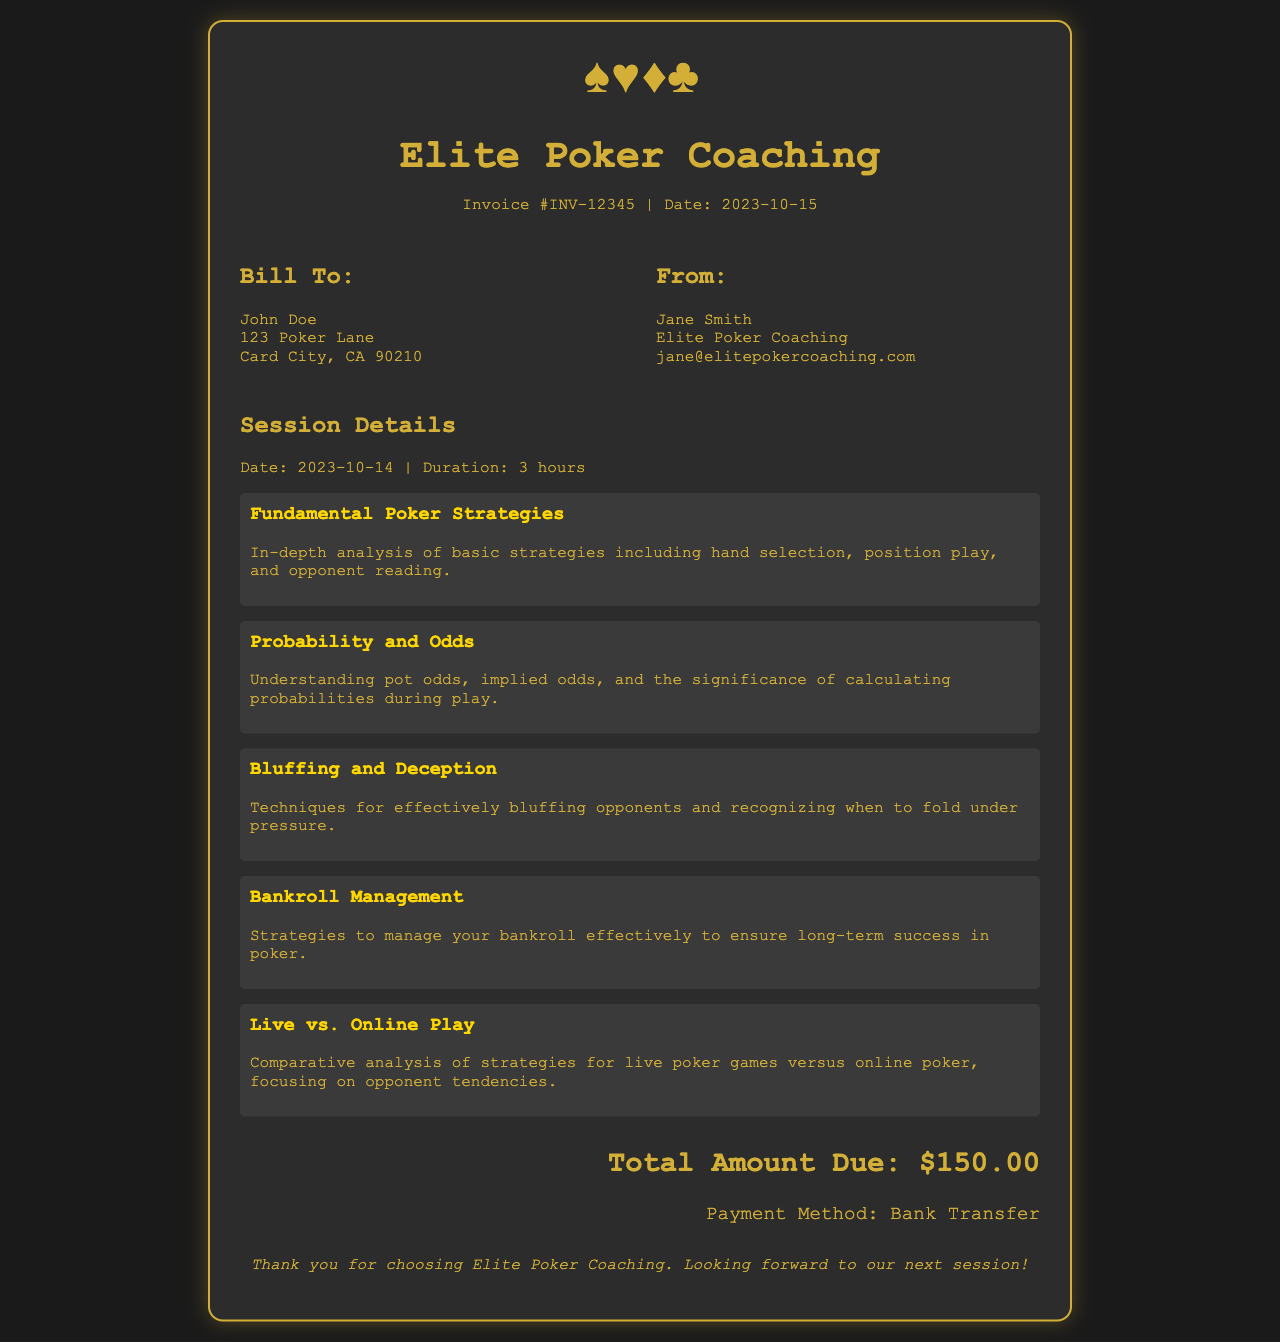what is the invoice number? The invoice number is stated clearly in the header section of the document.
Answer: INV-12345 who is the client? The client's name is located in the "Bill To" section of the invoice.
Answer: John Doe what is the date of the coaching session? The date of the coaching session is mentioned in the "Session Details" section of the invoice.
Answer: 2023-10-14 how many hours was the coaching session? The duration of the session is specified in the "Session Details" section.
Answer: 3 hours what is the total amount due? The total amount due is highlighted at the bottom of the invoice.
Answer: $150.00 which topics were covered during the session? The topics covered are listed under the "Session Details" segment, each with a brief description.
Answer: Fundamental Poker Strategies, Probability and Odds, Bluffing and Deception, Bankroll Management, Live vs. Online Play who is the coach? The coach's name is found in the "From" section of the document.
Answer: Jane Smith what is the payment method? The payment method is mentioned at the end of the invoice following the total amount due.
Answer: Bank Transfer what kind of document is this? The nature of the document is indicated by its title at the top.
Answer: Invoice 